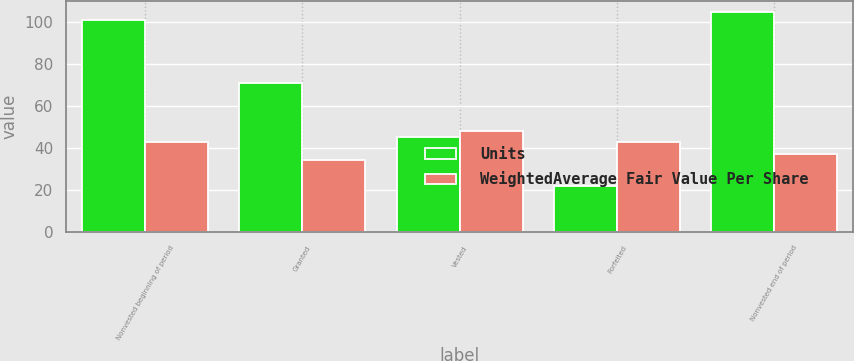Convert chart to OTSL. <chart><loc_0><loc_0><loc_500><loc_500><stacked_bar_chart><ecel><fcel>Nonvested beginning of period<fcel>Granted<fcel>Vested<fcel>Forfeited<fcel>Nonvested end of period<nl><fcel>Units<fcel>101<fcel>71<fcel>45<fcel>22<fcel>105<nl><fcel>WeightedAverage Fair Value Per Share<fcel>43<fcel>34<fcel>48<fcel>43<fcel>37<nl></chart> 